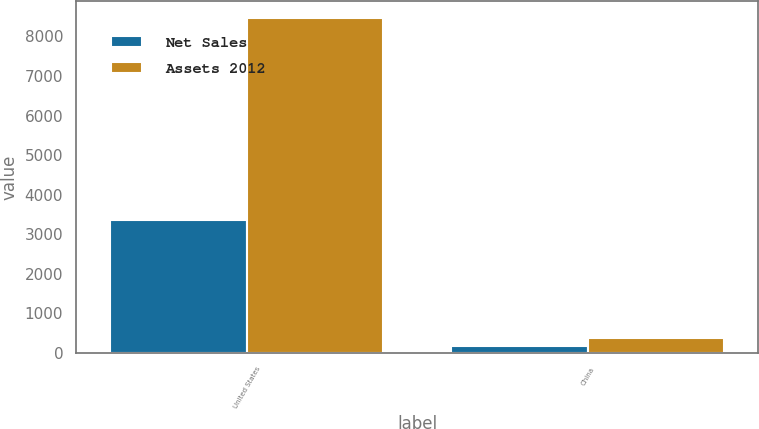Convert chart to OTSL. <chart><loc_0><loc_0><loc_500><loc_500><stacked_bar_chart><ecel><fcel>United States<fcel>China<nl><fcel>Net Sales<fcel>3354<fcel>160<nl><fcel>Assets 2012<fcel>8468<fcel>382<nl></chart> 